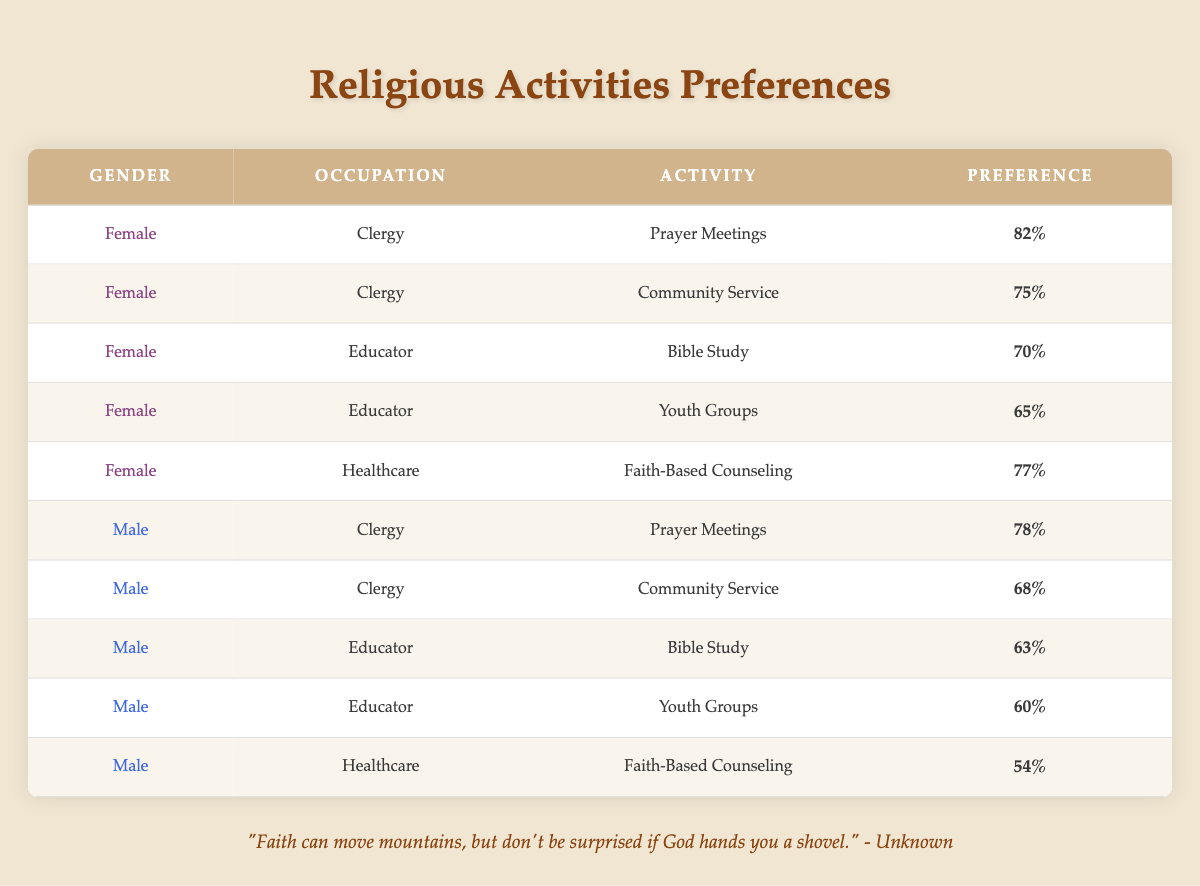What is the preference percentage for Prayer Meetings among Female Clergy? The table lists the preference for Prayer Meetings under the Female Clergy occupation, which shows 82% as the preference percentage.
Answer: 82% Which religious activity has the highest preference among Male Healthcare professionals? Looking through the Male Healthcare row, the activity listed is Faith-Based Counseling, which has a preference of 54%. This is the only activity for Male Healthcare in the table, making it the highest for this group.
Answer: 54% How does the preference for Community Service compare between Female and Male Clergy? The preference for Community Service among Female Clergy is 75%, while for Male Clergy it is 68%. The difference is 75% - 68% = 7%, indicating that Female Clergy have a higher preference for this activity.
Answer: Female Clergy prefer Community Service 7% more than Male Clergy What is the total preference for Youth Groups from both Female and Male Educators? For Female Educators, the preference for Youth Groups is 65%, and for Male Educators, it is 60%. Adding these values gives a total preference of 65% + 60% = 125%.
Answer: 125% Is the preference for Bible Study higher among Male Educators than Female Educators? The table indicates that Female Educators have a preference of 70% for Bible Study, while Male Educators have a preference of 63%. Since 70% is greater than 63%, the statement is false.
Answer: No Which gender and occupation combination has the lowest preference for Faith-Based Counseling? The table shows that the Male Healthcare professionals have the lowest preference for Faith-Based Counseling at 54%. Therefore, the combination is Male Healthcare.
Answer: Male Healthcare What is the average preference for religious activities among Female educators? The preferences for Female Educators are Bible Study (70%) and Youth Groups (65%). The average is calculated as (70% + 65%) / 2 = 67.5%.
Answer: 67.5% What activity do both Male and Female Clergy prefer the most, and what is the preference level for that activity? Both Male and Female Clergy prefer Prayer Meetings, with Female Clergy showing a preference of 82% and Male Clergy showing 78%. Since both prefer this activity, it is the most preferred.
Answer: Prayer Meetings, 82% for Female Clergy and 78% for Male Clergy 